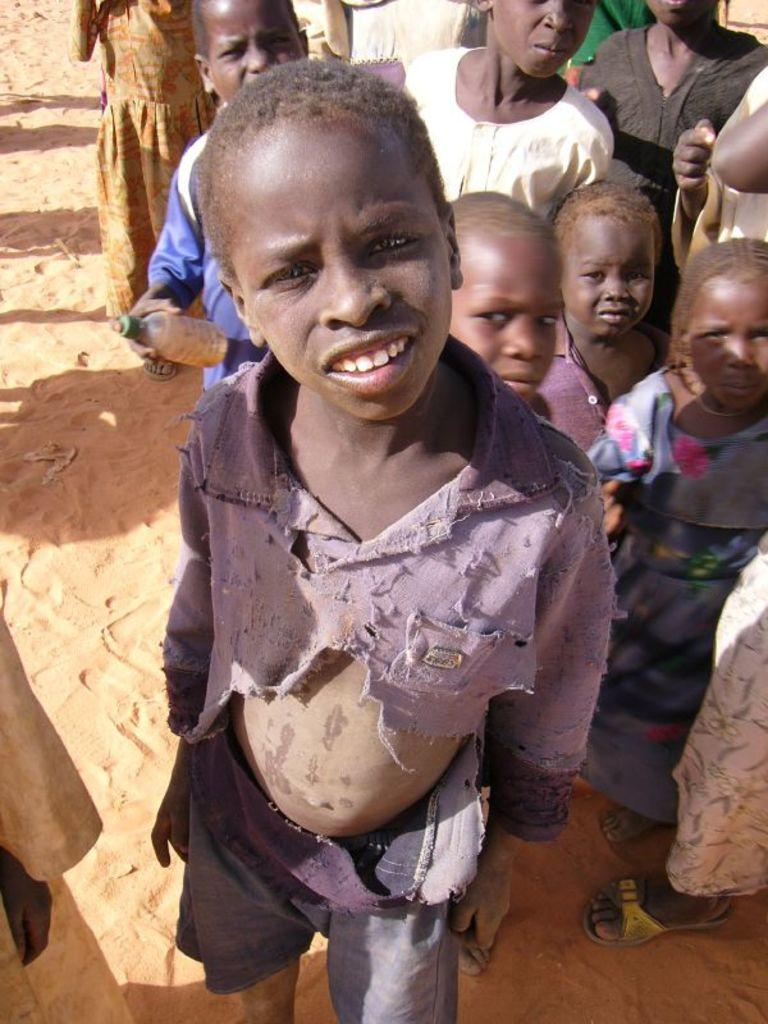Who or what is present in the image? There are people in the image. What type of terrain can be seen in the image? There is sand in the image. What object is one person holding? One person is holding a bottle. Can you tell me how many squirrels are playing with the glass in the image? There are no squirrels or glass present in the image. What is the person's interest in the image? The provided facts do not give information about the person's interests, so we cannot determine their interest from the image. 